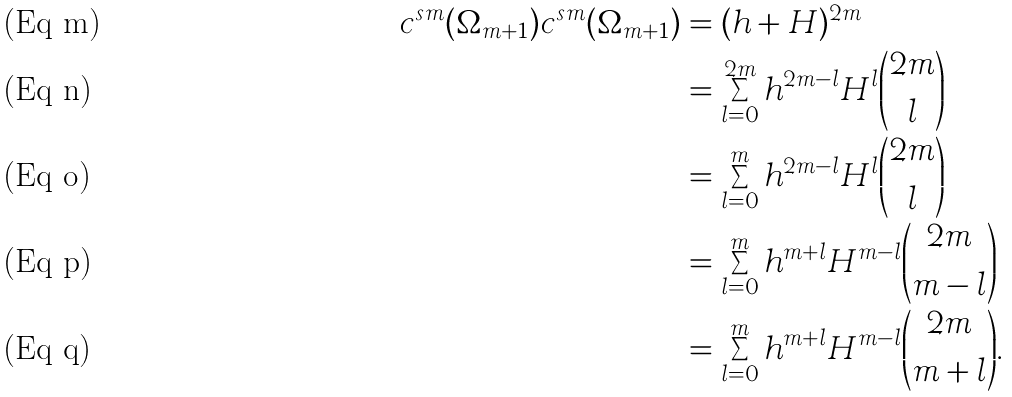<formula> <loc_0><loc_0><loc_500><loc_500>c ^ { s m } ( \Omega _ { m + 1 } ) c ^ { s m } ( \Omega _ { m + 1 } ) & = ( h + H ) ^ { 2 m } \\ & = \sum _ { l = 0 } ^ { 2 m } h ^ { 2 m - l } H ^ { l } \binom { 2 m } { l } \\ & = \sum _ { l = 0 } ^ { m } h ^ { 2 m - l } H ^ { l } \binom { 2 m } { l } \\ & = \sum _ { l = 0 } ^ { m } h ^ { m + l } H ^ { m - l } \binom { 2 m } { m - l } \\ & = \sum _ { l = 0 } ^ { m } h ^ { m + l } H ^ { m - l } \binom { 2 m } { m + l } .</formula> 